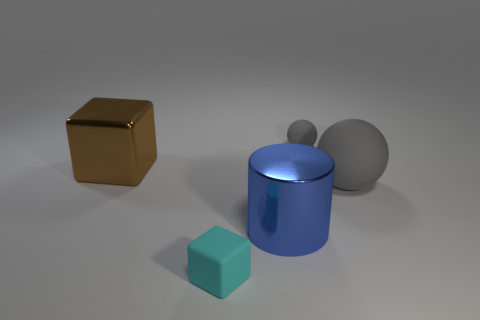Are there any other things that have the same size as the brown cube?
Give a very brief answer. Yes. Is the number of spheres to the left of the tiny rubber cube greater than the number of metal cylinders in front of the blue thing?
Keep it short and to the point. No. What is the block in front of the large blue shiny cylinder made of?
Ensure brevity in your answer.  Rubber. Do the big blue metallic object and the big thing that is left of the small cyan matte block have the same shape?
Ensure brevity in your answer.  No. There is a block on the left side of the rubber thing that is in front of the large metallic cylinder; what number of gray rubber objects are in front of it?
Keep it short and to the point. 1. There is a tiny object that is the same shape as the big brown metal thing; what is its color?
Provide a short and direct response. Cyan. Are there any other things that are the same shape as the large gray rubber thing?
Offer a terse response. Yes. How many spheres are purple rubber things or big brown shiny things?
Make the answer very short. 0. The large gray object is what shape?
Your answer should be very brief. Sphere. Are there any blue metallic cylinders on the left side of the large brown object?
Make the answer very short. No. 